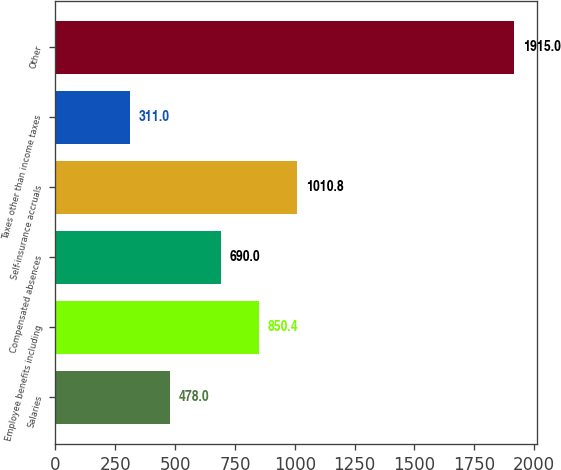Convert chart to OTSL. <chart><loc_0><loc_0><loc_500><loc_500><bar_chart><fcel>Salaries<fcel>Employee benefits including<fcel>Compensated absences<fcel>Self-insurance accruals<fcel>Taxes other than income taxes<fcel>Other<nl><fcel>478<fcel>850.4<fcel>690<fcel>1010.8<fcel>311<fcel>1915<nl></chart> 